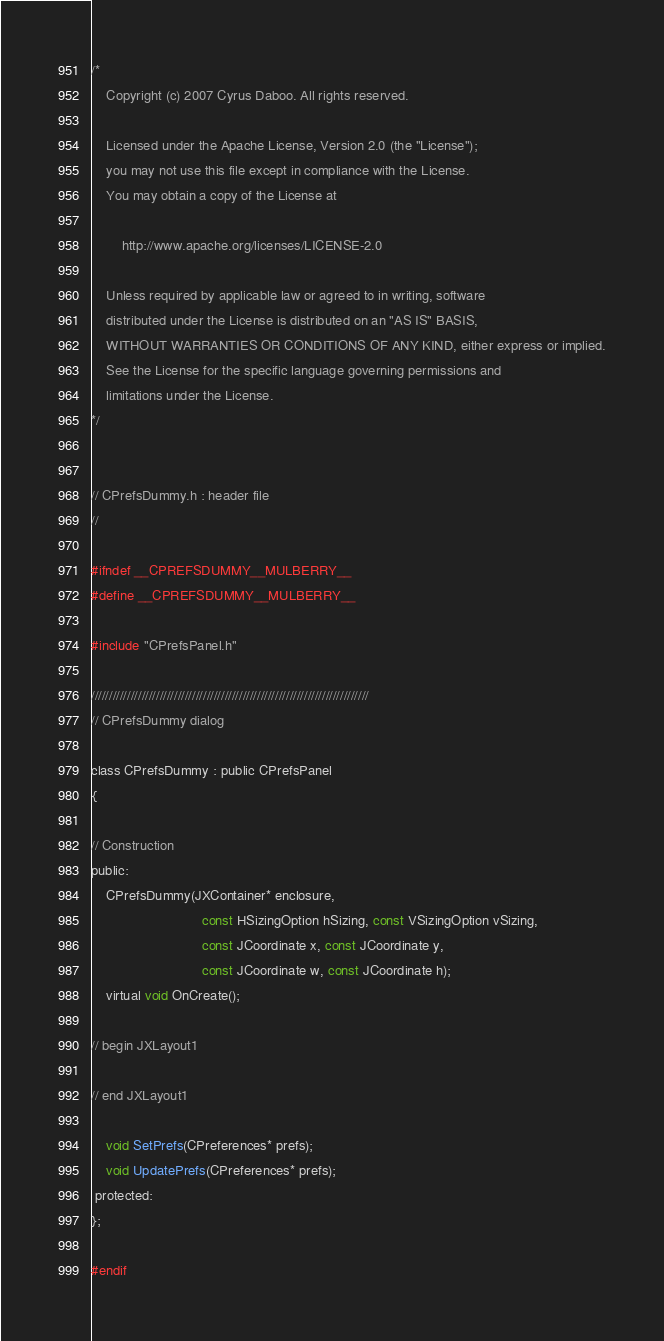<code> <loc_0><loc_0><loc_500><loc_500><_C_>/*
    Copyright (c) 2007 Cyrus Daboo. All rights reserved.
    
    Licensed under the Apache License, Version 2.0 (the "License");
    you may not use this file except in compliance with the License.
    You may obtain a copy of the License at
    
        http://www.apache.org/licenses/LICENSE-2.0
    
    Unless required by applicable law or agreed to in writing, software
    distributed under the License is distributed on an "AS IS" BASIS,
    WITHOUT WARRANTIES OR CONDITIONS OF ANY KIND, either express or implied.
    See the License for the specific language governing permissions and
    limitations under the License.
*/


// CPrefsDummy.h : header file
//

#ifndef __CPREFSDUMMY__MULBERRY__
#define __CPREFSDUMMY__MULBERRY__

#include "CPrefsPanel.h"

/////////////////////////////////////////////////////////////////////////////
// CPrefsDummy dialog

class CPrefsDummy : public CPrefsPanel
{

// Construction
public:
	CPrefsDummy(JXContainer* enclosure,
							 const HSizingOption hSizing, const VSizingOption vSizing,
							 const JCoordinate x, const JCoordinate y,
							 const JCoordinate w, const JCoordinate h);
	virtual void OnCreate();

// begin JXLayout1

// end JXLayout1

	void SetPrefs(CPreferences* prefs);				
	void UpdatePrefs(CPreferences* prefs);		
 protected:
};

#endif
</code> 